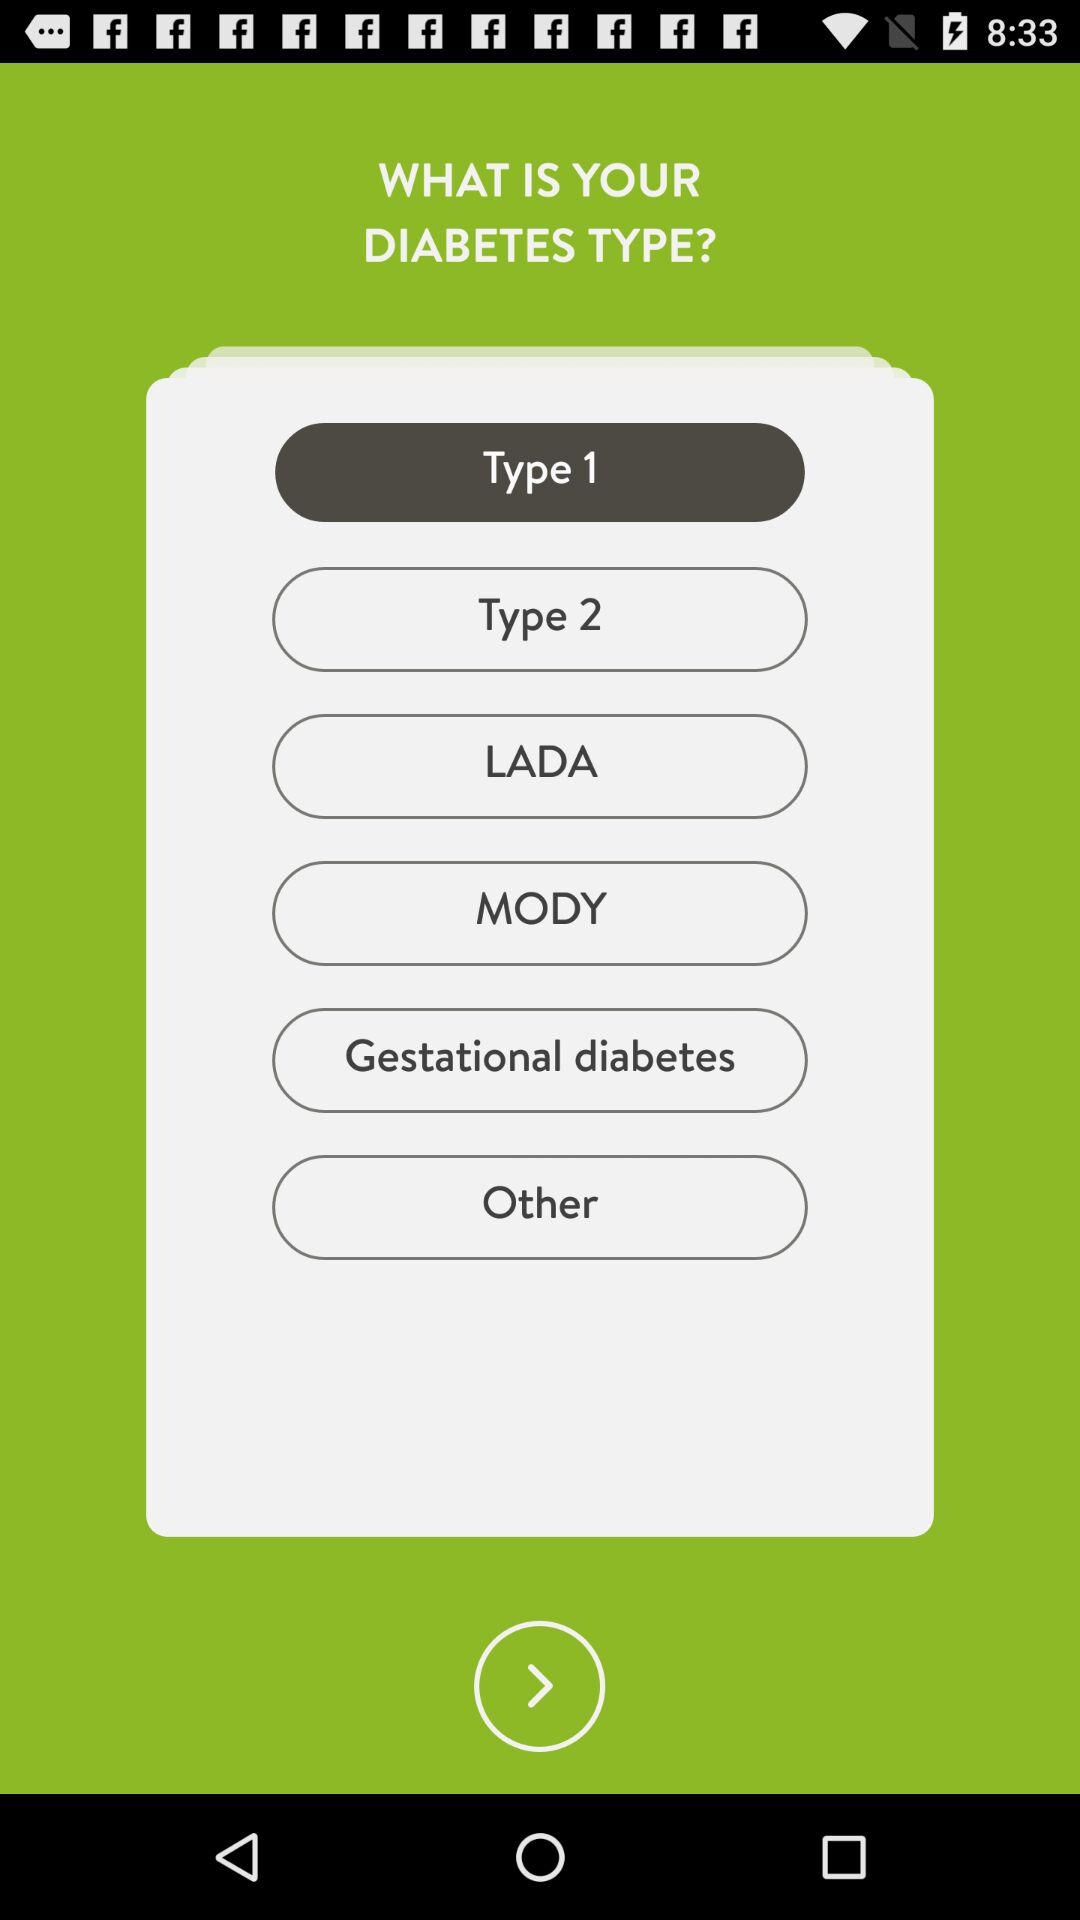What is the selected type of diabetes? The selected type of diabetes is "Type 1". 